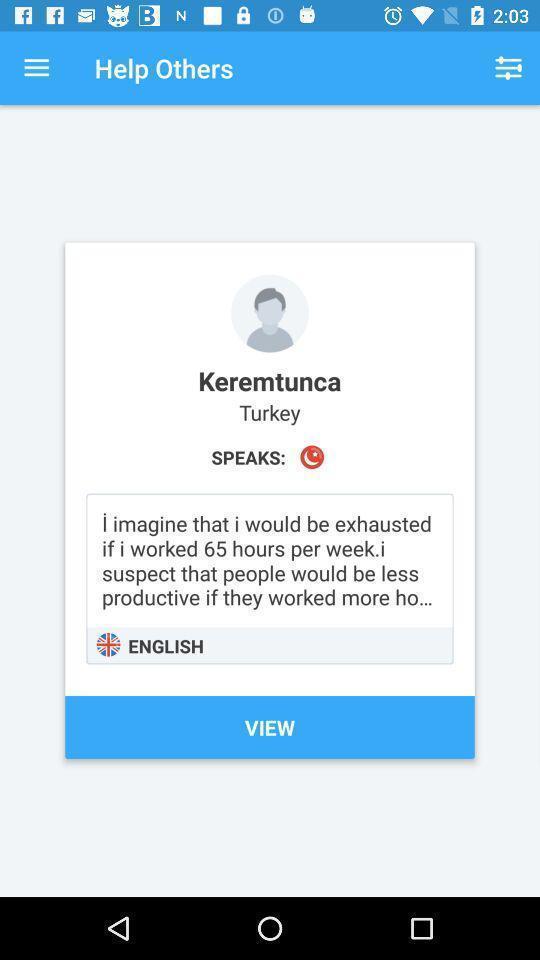Describe the visual elements of this screenshot. Screen displaying user information in a language learning application. 